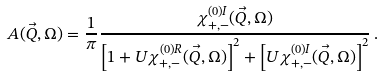Convert formula to latex. <formula><loc_0><loc_0><loc_500><loc_500>A ( \vec { Q } , \Omega ) = \frac { 1 } { \pi } \frac { \chi ^ { ( 0 ) I } _ { + , - } ( \vec { Q } , \Omega ) } { \left [ 1 + U \chi ^ { ( 0 ) R } _ { + , - } ( \vec { Q } , \Omega ) \right ] ^ { 2 } + \left [ U \chi ^ { ( 0 ) I } _ { + , - } ( \vec { Q } , \Omega ) \right ] ^ { 2 } } \, .</formula> 